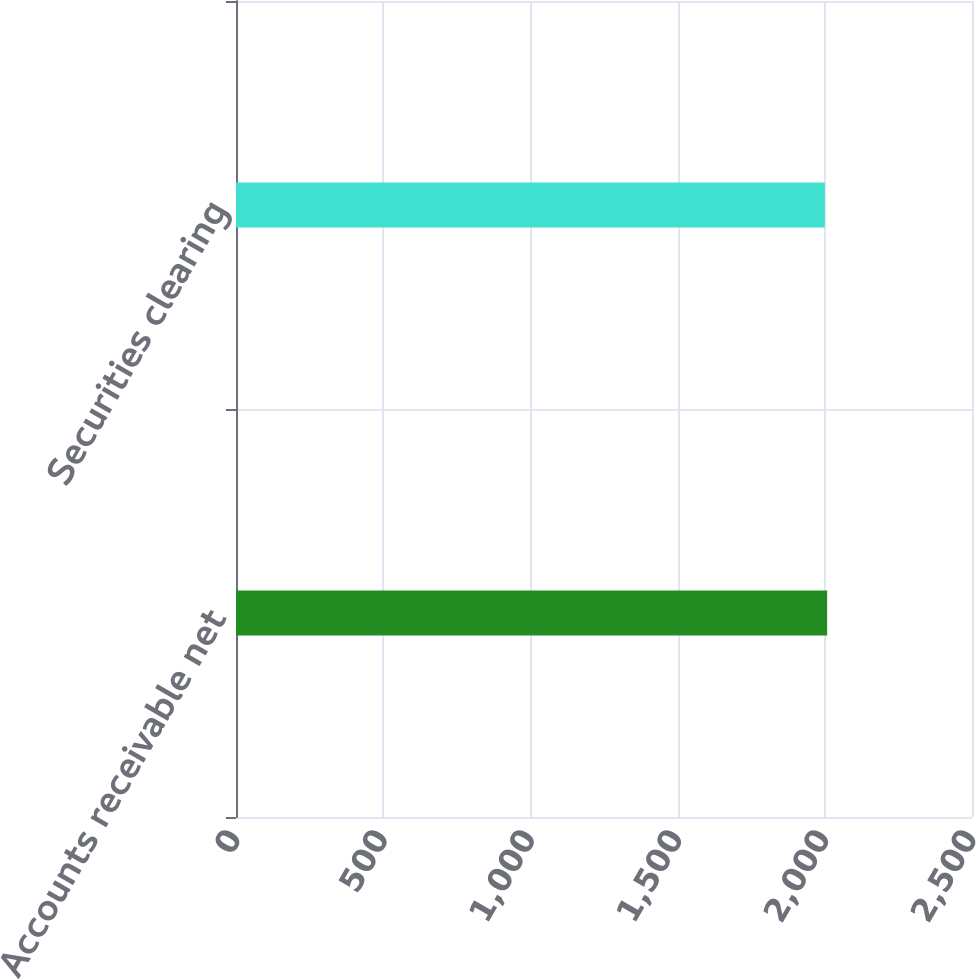<chart> <loc_0><loc_0><loc_500><loc_500><bar_chart><fcel>Accounts receivable net<fcel>Securities clearing<nl><fcel>2008<fcel>2000<nl></chart> 